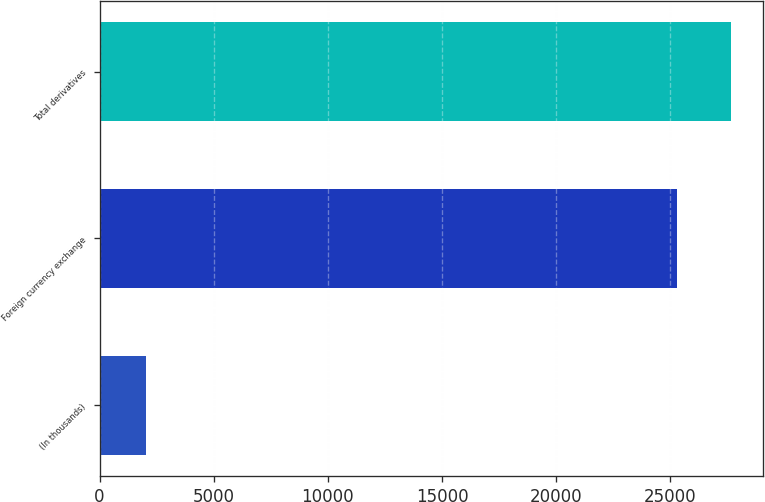<chart> <loc_0><loc_0><loc_500><loc_500><bar_chart><fcel>(In thousands)<fcel>Foreign currency exchange<fcel>Total derivatives<nl><fcel>2016<fcel>25292<fcel>27647.8<nl></chart> 